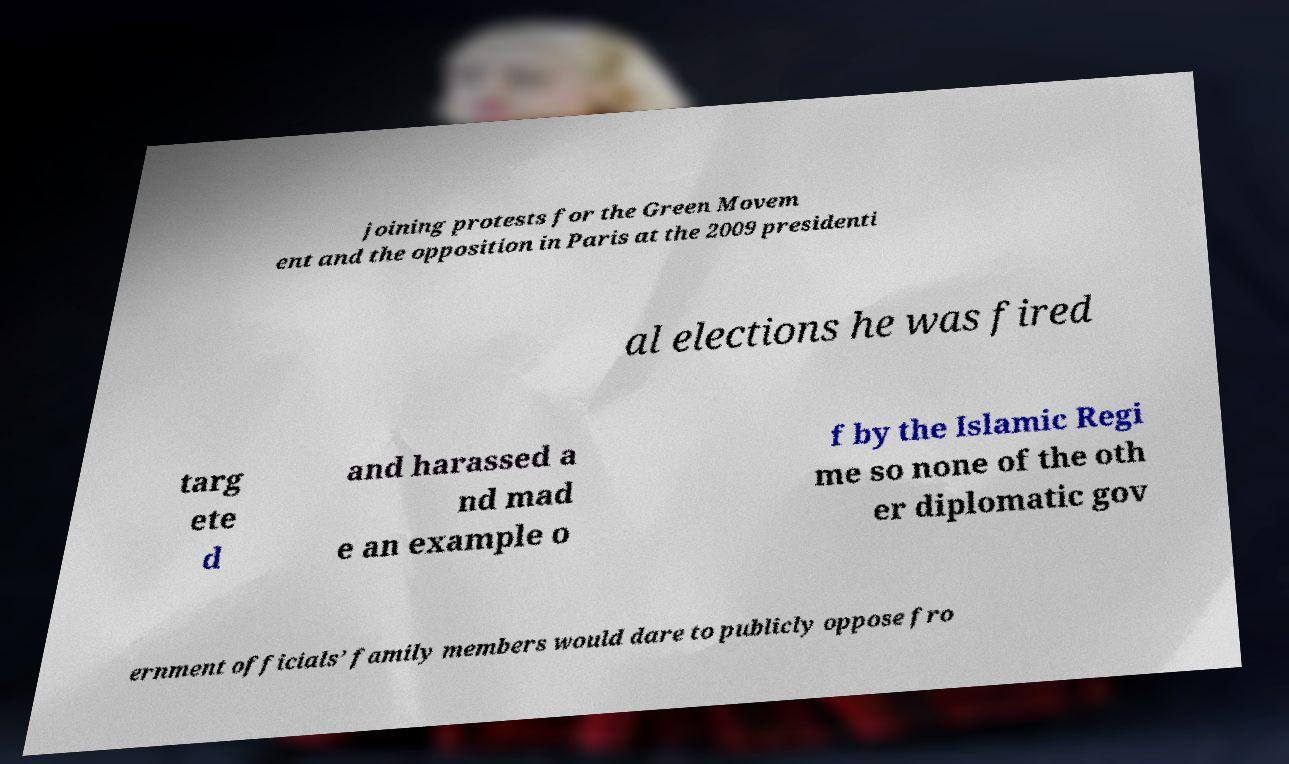Please read and relay the text visible in this image. What does it say? joining protests for the Green Movem ent and the opposition in Paris at the 2009 presidenti al elections he was fired targ ete d and harassed a nd mad e an example o f by the Islamic Regi me so none of the oth er diplomatic gov ernment officials’ family members would dare to publicly oppose fro 